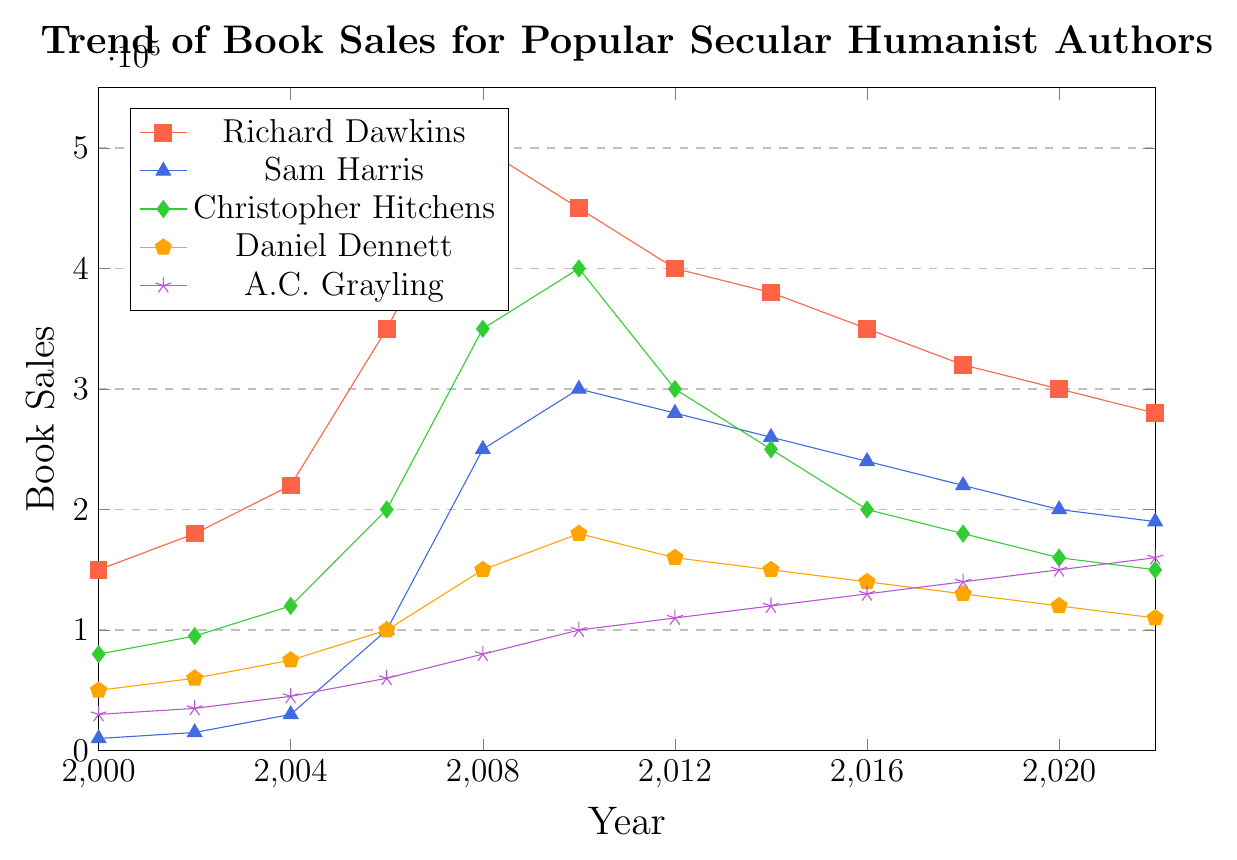Which author had the highest book sales in 2008? To determine the author with the highest sales in 2008, look at the y-values for each author in 2008 and identify the one that is the highest. Richard Dawkins had the highest sales at 500,000.
Answer: Richard Dawkins What was the total book sales for Sam Harris from 2000 to 2006? Sum the sales values for Sam Harris from 2000 to 2006: 10,000 (2000) + 15,000 (2002) + 30,000 (2004) + 100,000 (2006). The total is 155,000.
Answer: 155,000 Among the five authors, who had the least increase in book sales between 2000 and 2022? Compute the difference in sales from 2022 and 2000 for each author: Richard Dawkins (280,000-150,000=130,000), Sam Harris (190,000-10,000=180,000), Christopher Hitchens (150,000-80,000=70,000), Daniel Dennett (110,000-50,000=60,000), A.C. Grayling (160,000-30,000=130,000). Daniel Dennett had the least increase with 60,000.
Answer: Daniel Dennett In which year did Christopher Hitchens' book sales peak? Identify the highest point on the graph for Christopher Hitchens. The peak year is 2010 with sales at 400,000.
Answer: 2010 By what percentage did Richard Dawkins' sales decrease from 2008 to 2022? Find the sales for Richard Dawkins in 2008 and 2022, then calculate the percentage decrease. The formula is ((500,000 - 280,000) / 500,000) * 100%. This gives a decrease of 44%.
Answer: 44% Who had the most consistent increase in book sales over the years? Look for the author with the steadiest year-over-year increase without large fluctuations. A.C. Grayling shows a steady linear increase from 30,000 in 2000 to 160,000 in 2022.
Answer: A.C. Grayling Compare the sales trend of Sam Harris and Daniel Dennett from 2010 to 2022. Evaluate the change in sales for both authors during this period. Sam Harris shows a decrease from 300,000 to 190,000, while Daniel Dennett shows a decrease from 180,000 to 110,000. Both authors' sales decreased, but Sam Harris had a larger decline.
Answer: Sam Harris had a larger decline Which two authors had the closest book sales in 2022? Compare the sales numbers for each author in 2022. Sam Harris had 190,000 and Christopher Hitchens had 150,000, which are the closest values with a difference of 40,000.
Answer: Sam Harris and Christopher Hitchens 